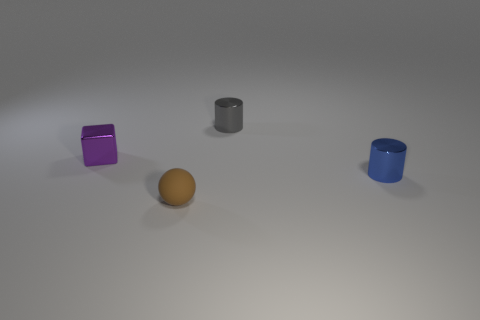Add 4 tiny brown rubber spheres. How many objects exist? 8 Subtract all spheres. How many objects are left? 3 Subtract 0 green cylinders. How many objects are left? 4 Subtract all big cyan objects. Subtract all gray metallic things. How many objects are left? 3 Add 3 brown rubber objects. How many brown rubber objects are left? 4 Add 3 purple metal objects. How many purple metal objects exist? 4 